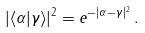Convert formula to latex. <formula><loc_0><loc_0><loc_500><loc_500>| \langle \alpha | \gamma \rangle | ^ { 2 } = e ^ { - | \alpha - \gamma | ^ { 2 } } \, .</formula> 